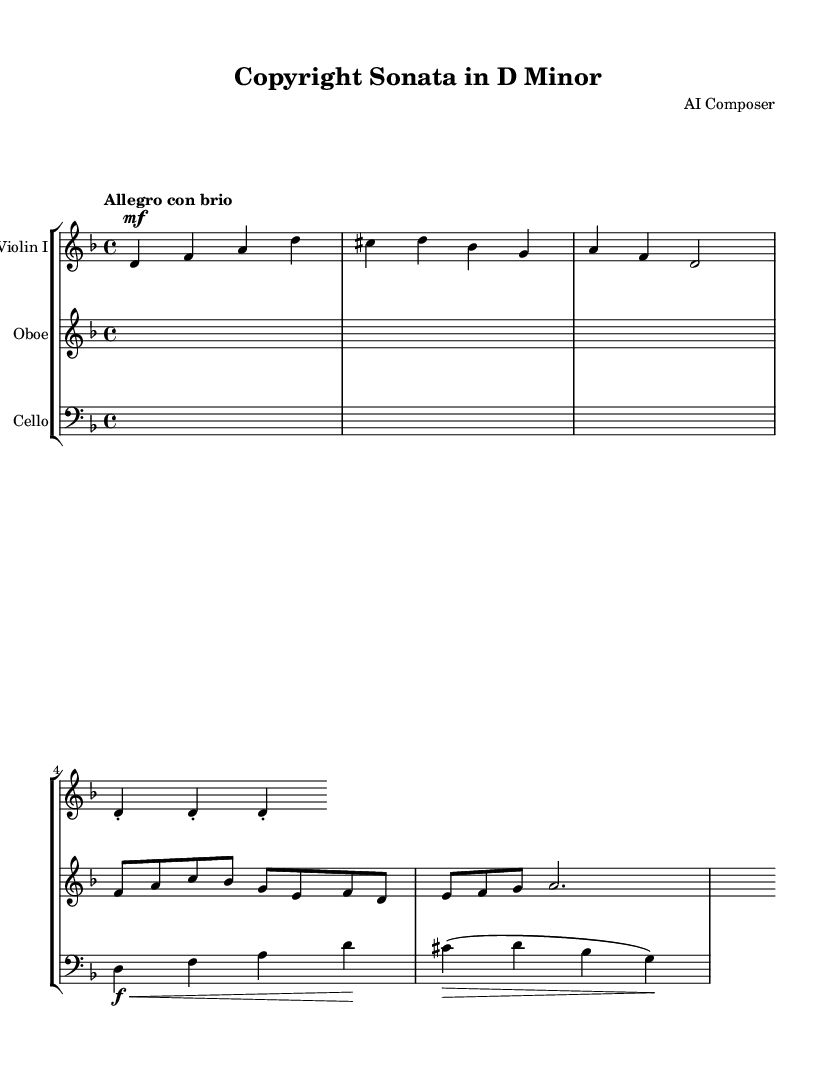What is the key signature of this music? The key signature is indicated at the beginning of the score, showing one flat (B flat) and the absence of sharps. This corresponds to D minor.
Answer: D minor What is the time signature of this music? The time signature is found at the beginning of the piece, indicating how many beats are in each measure. In this case, it is 4/4 time, which means there are four beats per measure.
Answer: 4/4 What is the tempo marking for this piece? The tempo marking is found at the beginning of the score and indicates the speed of the piece. Here, it is marked as "Allegro con brio," which suggests a fast and lively tempo.
Answer: Allegro con brio How many measures are in the Violin I part? To find the number of measures in the Violin I part, we count the distinct groupings of notes and rests within the provided melody. The Violin I part contains a total of 5 measures.
Answer: 5 Which instrument plays the melody in the first measure? By examining the notation in the first measure, we see that the Violin I part is active with notes while the other instruments (oboe and cello) are silent (rests). Therefore, Violin I plays the melody.
Answer: Violin I What dynamics marking appears in the Violin I part? The dynamics marking in the Violin I part is noted just before the notes begin, where it indicates a mezzo-forte (mf) level. This directs the player to perform the passage moderately loud.
Answer: mf What technique is indicated for the three repeated notes in the Violin I part? The notation for the three repeated notes in the Violin I part shows a staccato marking (dots above the notes), indicating that these notes should be played short and detached from each other.
Answer: Staccato 